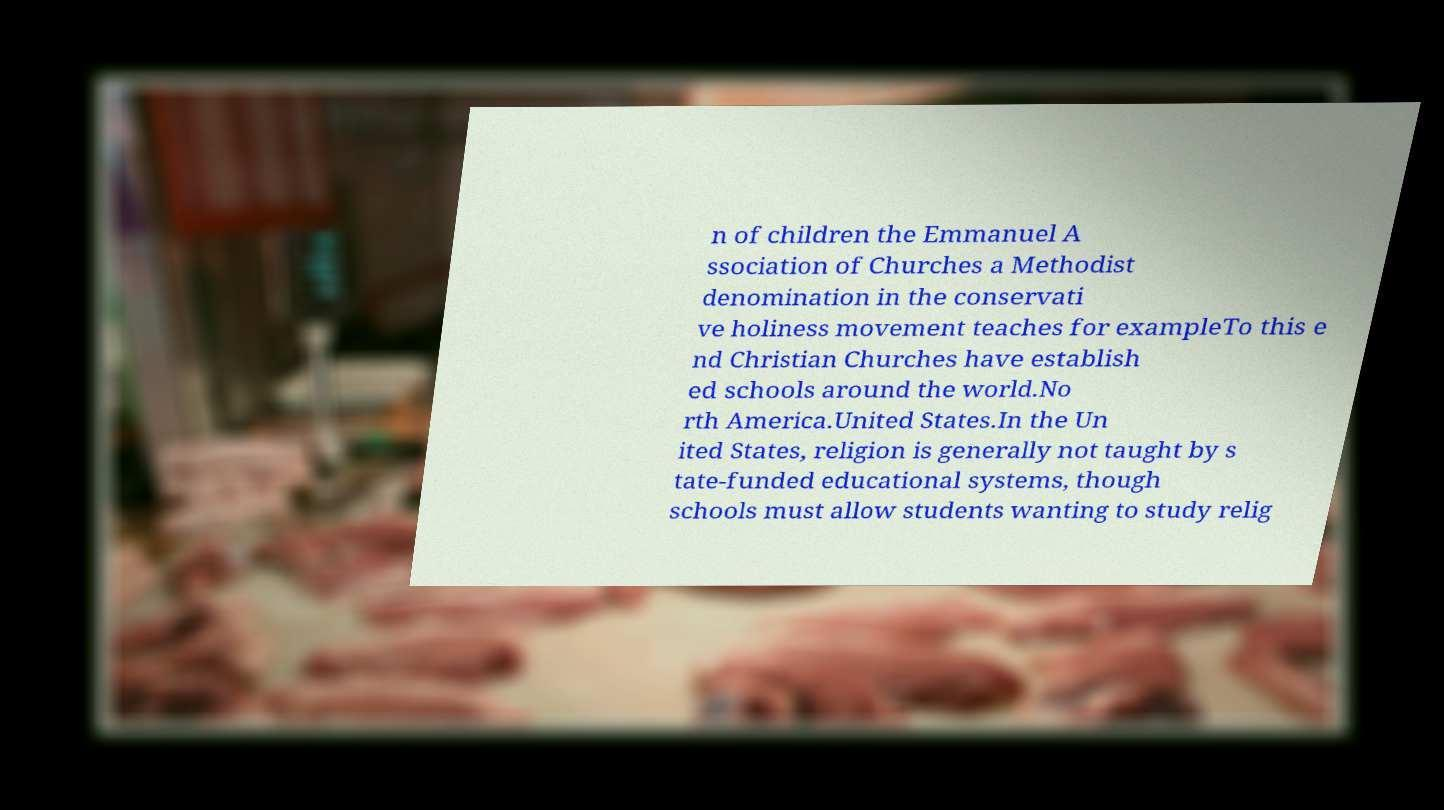I need the written content from this picture converted into text. Can you do that? n of children the Emmanuel A ssociation of Churches a Methodist denomination in the conservati ve holiness movement teaches for exampleTo this e nd Christian Churches have establish ed schools around the world.No rth America.United States.In the Un ited States, religion is generally not taught by s tate-funded educational systems, though schools must allow students wanting to study relig 